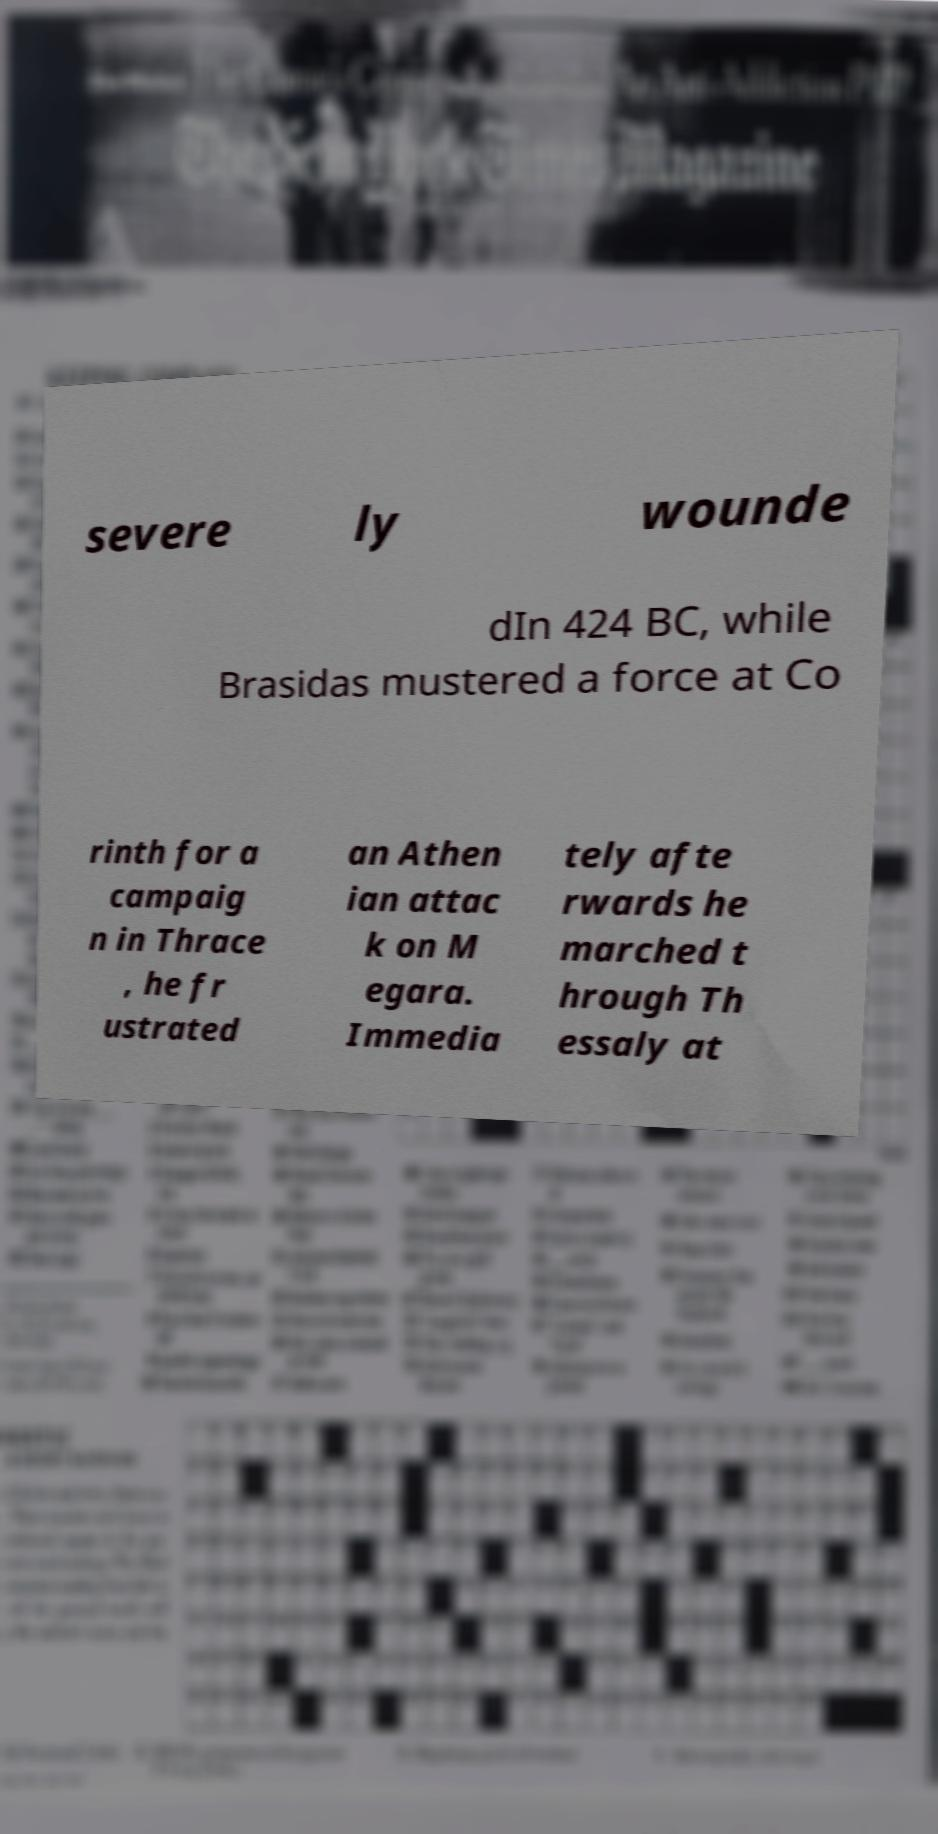Could you extract and type out the text from this image? severe ly wounde dIn 424 BC, while Brasidas mustered a force at Co rinth for a campaig n in Thrace , he fr ustrated an Athen ian attac k on M egara. Immedia tely afte rwards he marched t hrough Th essaly at 